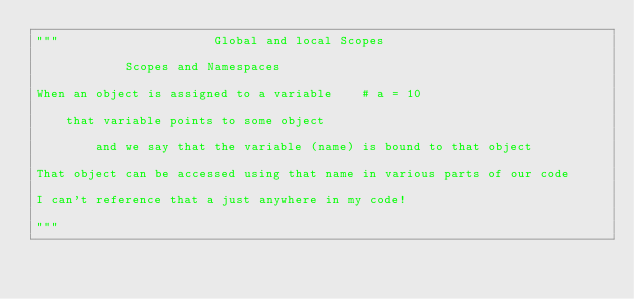<code> <loc_0><loc_0><loc_500><loc_500><_Python_>"""                     Global and local Scopes

            Scopes and Namespaces

When an object is assigned to a variable    # a = 10

    that variable points to some object

        and we say that the variable (name) is bound to that object

That object can be accessed using that name in various parts of our code

I can't reference that a just anywhere in my code!

"""</code> 